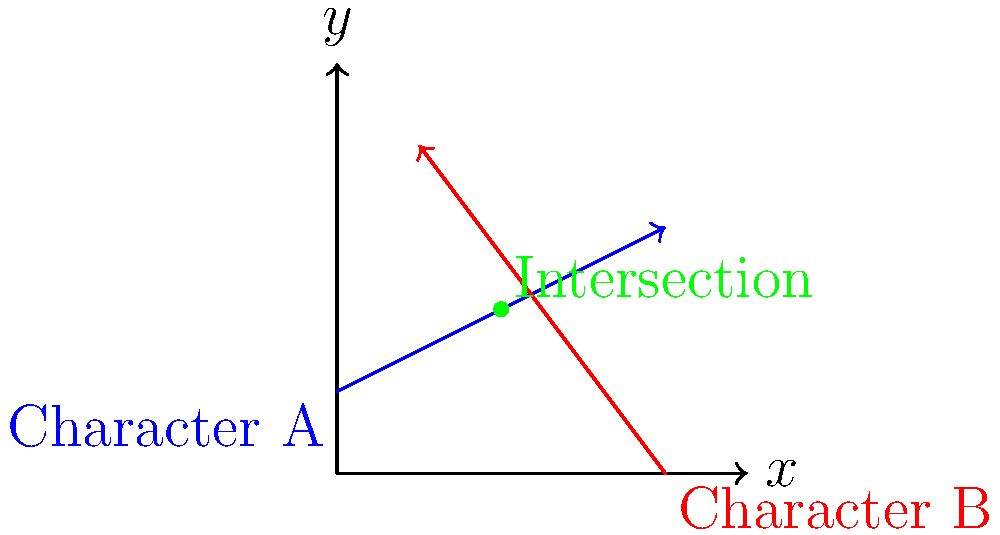In your latest suspense thriller, you want to create a surprising encounter between two characters. Character A starts at point (0, 2) and moves along the vector $\vec{a} = 8\hat{i} + 4\hat{j}$, while Character B starts at point (8, 0) and moves along the vector $\vec{b} = -6\hat{i} + 8\hat{j}$. At what point do their paths intersect, creating the perfect moment for a shocking revelation? To find the intersection point, we need to set up and solve a system of vector equations:

1) Let's define the position vectors for each character:
   Character A: $\vec{r_A} = (0, 2) + t\vec{a} = (0, 2) + t(8, 4)$
   Character B: $\vec{r_B} = (8, 0) + s\vec{b} = (8, 0) + s(-6, 8)$

2) At the intersection point, these vectors are equal:
   $(0, 2) + t(8, 4) = (8, 0) + s(-6, 8)$

3) This gives us two equations:
   $8t = 8 - 6s$
   $2 + 4t = 8s$

4) From the first equation:
   $t = 1 - \frac{3s}{4}$

5) Substitute this into the second equation:
   $2 + 4(1 - \frac{3s}{4}) = 8s$
   $2 + 4 - 3s = 8s$
   $6 - 3s = 8s$
   $6 = 11s$
   $s = \frac{6}{11}$

6) Now we can find $t$:
   $t = 1 - \frac{3}{4} \cdot \frac{6}{11} = 1 - \frac{9}{22} = \frac{13}{22}$

7) The intersection point is found by plugging $t$ into Character A's equation:
   $\vec{r_A} = (0, 2) + \frac{13}{22}(8, 4) = (\frac{104}{22}, \frac{74}{22}) = (4.73, 3.36)$

8) Rounding to the nearest whole number for cinematic practicality:
   Intersection point ≈ (4, 4)
Answer: (4, 4) 